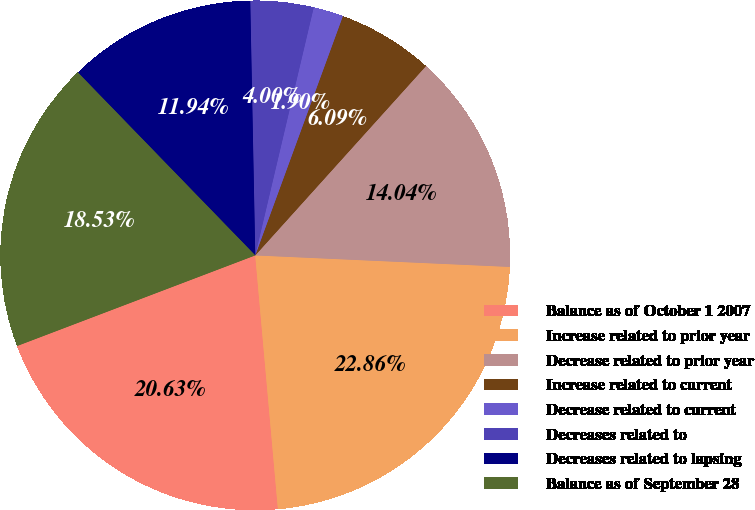Convert chart to OTSL. <chart><loc_0><loc_0><loc_500><loc_500><pie_chart><fcel>Balance as of October 1 2007<fcel>Increase related to prior year<fcel>Decrease related to prior year<fcel>Increase related to current<fcel>Decrease related to current<fcel>Decreases related to<fcel>Decreases related to lapsing<fcel>Balance as of September 28<nl><fcel>20.63%<fcel>22.86%<fcel>14.04%<fcel>6.09%<fcel>1.9%<fcel>4.0%<fcel>11.94%<fcel>18.53%<nl></chart> 